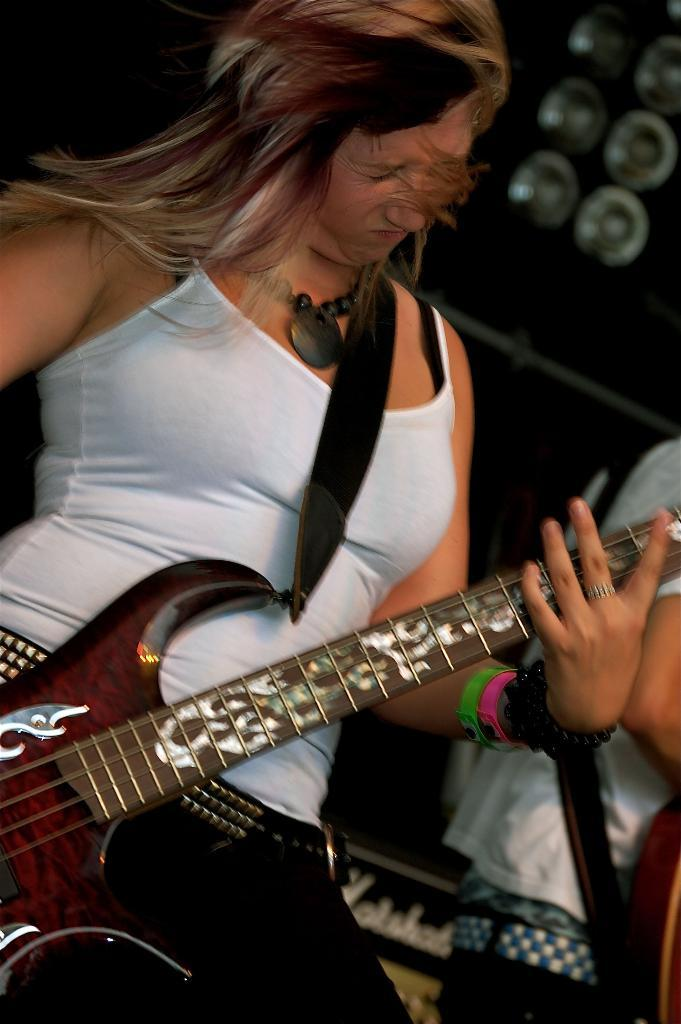Who is the main subject in the image? There is a lady in the image. What is the lady wearing? The lady is wearing a white dress. What is the lady doing in the image? The lady is playing a guitar. Can you describe the lady's surroundings? There is a band to the lady's left, and there is another person in the image, behind the lady. How far away is the calculator from the lady in the image? There is no calculator present in the image. 